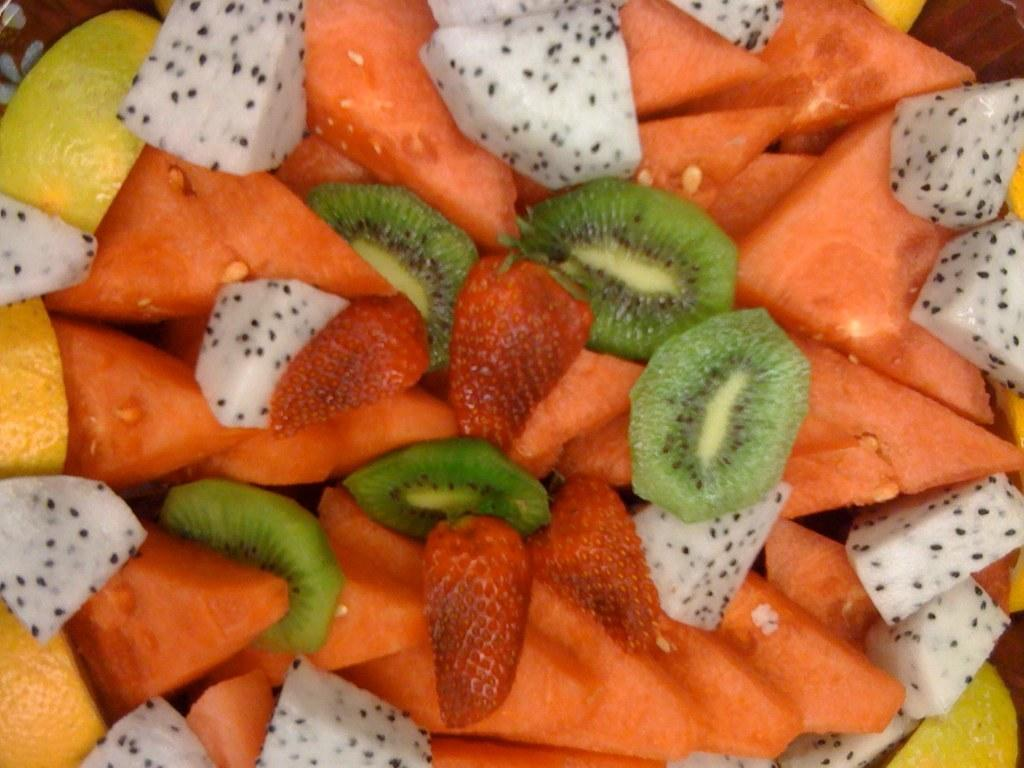What types of food can be seen in the image? There are different types of fruits in the image. Can you name some of the fruits visible in the image? Unfortunately, the facts provided do not specify which fruits are present in the image. Are the fruits arranged in any particular way or pattern? The facts provided do not mention any arrangement or pattern of the fruits in the image. How many fish can be seen swimming in the image? There are no fish present in the image; it features different types of fruits. What is the weight of the crate containing the fruits in the image? There is no crate present in the image, and therefore no weight can be determined. 